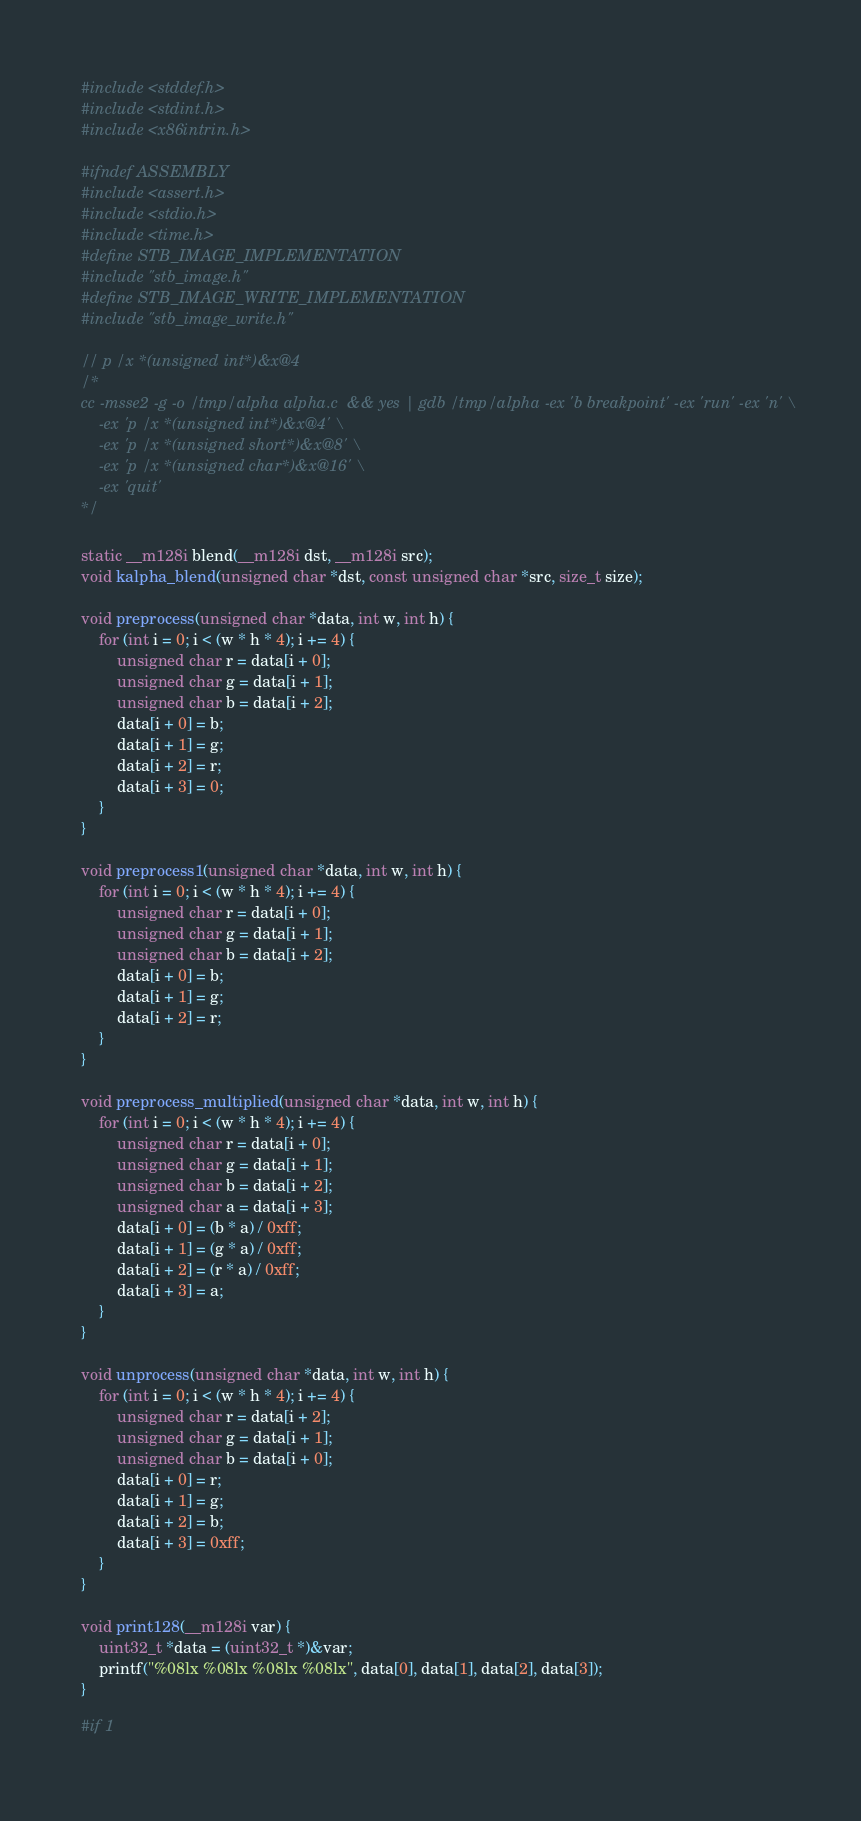Convert code to text. <code><loc_0><loc_0><loc_500><loc_500><_C_>#include <stddef.h>
#include <stdint.h>
#include <x86intrin.h>

#ifndef ASSEMBLY
#include <assert.h>
#include <stdio.h>
#include <time.h>
#define STB_IMAGE_IMPLEMENTATION
#include "stb_image.h"
#define STB_IMAGE_WRITE_IMPLEMENTATION
#include "stb_image_write.h"

// p /x *(unsigned int*)&x@4
/*
cc -msse2 -g -o /tmp/alpha alpha.c  && yes | gdb /tmp/alpha -ex 'b breakpoint' -ex 'run' -ex 'n' \
    -ex 'p /x *(unsigned int*)&x@4' \
    -ex 'p /x *(unsigned short*)&x@8' \
    -ex 'p /x *(unsigned char*)&x@16' \
    -ex 'quit'
*/

static __m128i blend(__m128i dst, __m128i src);
void kalpha_blend(unsigned char *dst, const unsigned char *src, size_t size);

void preprocess(unsigned char *data, int w, int h) {
    for (int i = 0; i < (w * h * 4); i += 4) {
        unsigned char r = data[i + 0];
        unsigned char g = data[i + 1];
        unsigned char b = data[i + 2];
        data[i + 0] = b;
        data[i + 1] = g;
        data[i + 2] = r;
        data[i + 3] = 0;
    }
}

void preprocess1(unsigned char *data, int w, int h) {
    for (int i = 0; i < (w * h * 4); i += 4) {
        unsigned char r = data[i + 0];
        unsigned char g = data[i + 1];
        unsigned char b = data[i + 2];
        data[i + 0] = b;
        data[i + 1] = g;
        data[i + 2] = r;
    }
}

void preprocess_multiplied(unsigned char *data, int w, int h) {
    for (int i = 0; i < (w * h * 4); i += 4) {
        unsigned char r = data[i + 0];
        unsigned char g = data[i + 1];
        unsigned char b = data[i + 2];
        unsigned char a = data[i + 3];
        data[i + 0] = (b * a) / 0xff;
        data[i + 1] = (g * a) / 0xff;
        data[i + 2] = (r * a) / 0xff;
        data[i + 3] = a;
    }
}

void unprocess(unsigned char *data, int w, int h) {
    for (int i = 0; i < (w * h * 4); i += 4) {
        unsigned char r = data[i + 2];
        unsigned char g = data[i + 1];
        unsigned char b = data[i + 0];
        data[i + 0] = r;
        data[i + 1] = g;
        data[i + 2] = b;
        data[i + 3] = 0xff;
    }
}

void print128(__m128i var) {
    uint32_t *data = (uint32_t *)&var;
    printf("%08lx %08lx %08lx %08lx", data[0], data[1], data[2], data[3]);
}

#if 1</code> 